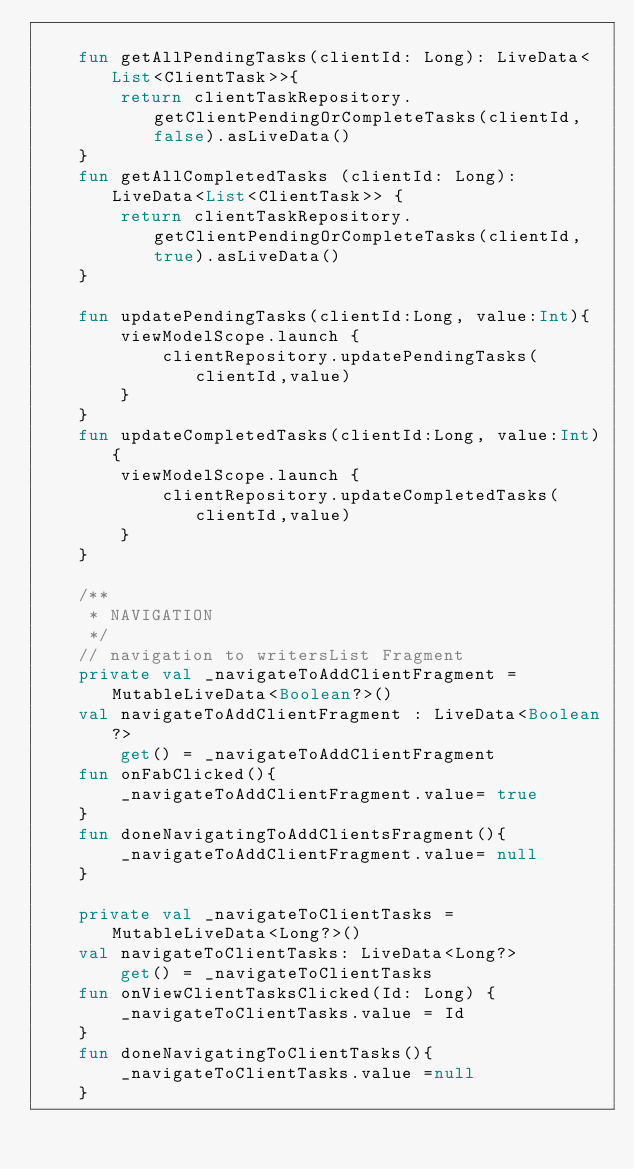Convert code to text. <code><loc_0><loc_0><loc_500><loc_500><_Kotlin_>
    fun getAllPendingTasks(clientId: Long): LiveData<List<ClientTask>>{
        return clientTaskRepository.getClientPendingOrCompleteTasks(clientId, false).asLiveData()
    }
    fun getAllCompletedTasks (clientId: Long): LiveData<List<ClientTask>> {
        return clientTaskRepository.getClientPendingOrCompleteTasks(clientId, true).asLiveData()
    }

    fun updatePendingTasks(clientId:Long, value:Int){
        viewModelScope.launch {
            clientRepository.updatePendingTasks(clientId,value)
        }
    }
    fun updateCompletedTasks(clientId:Long, value:Int){
        viewModelScope.launch {
            clientRepository.updateCompletedTasks(clientId,value)
        }
    }

    /**
     * NAVIGATION
     */
    // navigation to writersList Fragment
    private val _navigateToAddClientFragment = MutableLiveData<Boolean?>()
    val navigateToAddClientFragment : LiveData<Boolean?>
        get() = _navigateToAddClientFragment
    fun onFabClicked(){
        _navigateToAddClientFragment.value= true
    }
    fun doneNavigatingToAddClientsFragment(){
        _navigateToAddClientFragment.value= null
    }

    private val _navigateToClientTasks = MutableLiveData<Long?>()
    val navigateToClientTasks: LiveData<Long?>
        get() = _navigateToClientTasks
    fun onViewClientTasksClicked(Id: Long) {
        _navigateToClientTasks.value = Id
    }
    fun doneNavigatingToClientTasks(){
        _navigateToClientTasks.value =null
    }
</code> 